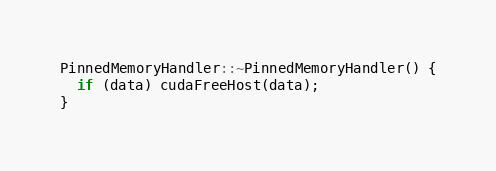Convert code to text. <code><loc_0><loc_0><loc_500><loc_500><_Cuda_>
PinnedMemoryHandler::~PinnedMemoryHandler() {
  if (data) cudaFreeHost(data);
}
</code> 